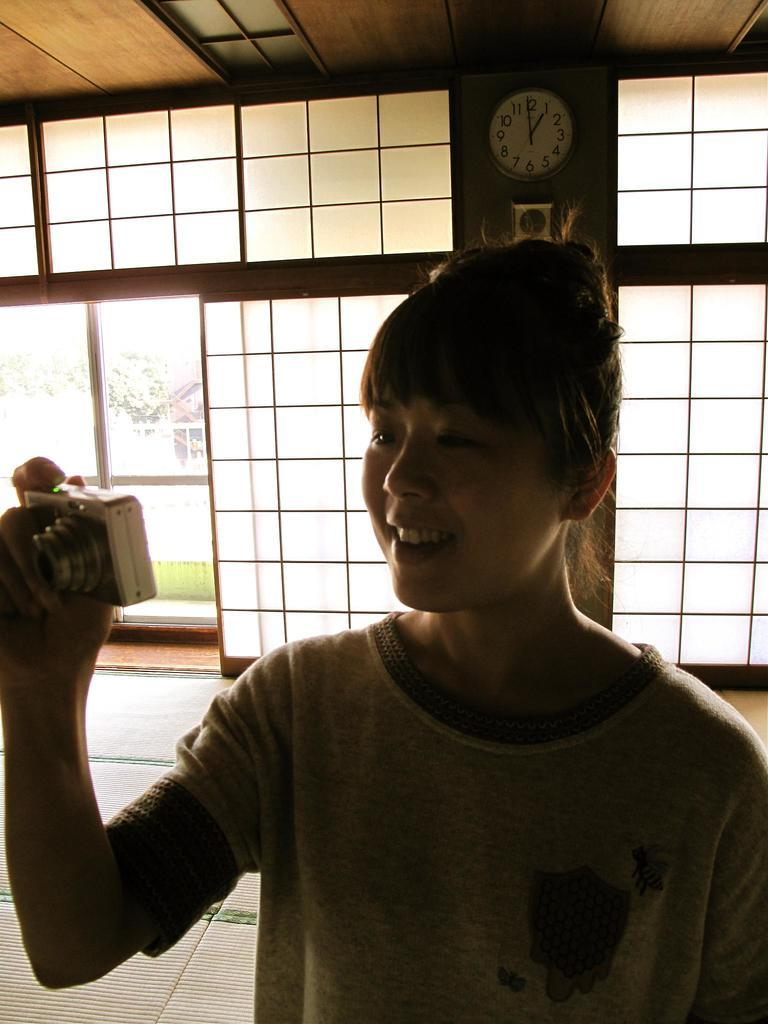Who is the main subject in the image? There is a woman in the image. What is the woman holding in the image? The woman is holding a camera. Can you describe any other objects in the background of the image? There is a watch in the background of the image. What type of vessel is being used to transport the earth in the image? There is no vessel or earth present in the image; it features a woman holding a camera and a watch in the background. 